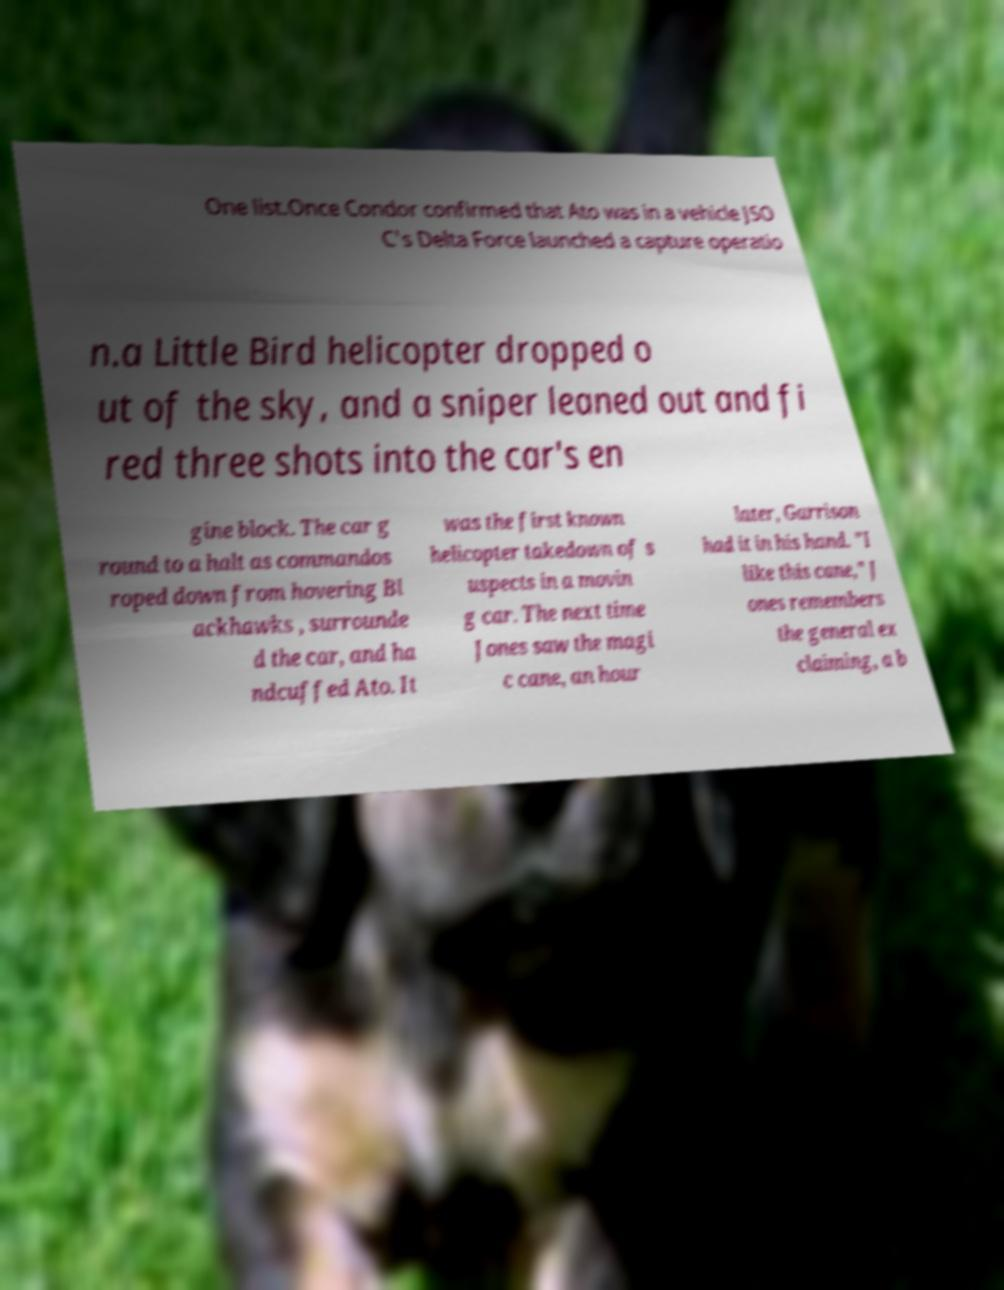Can you read and provide the text displayed in the image?This photo seems to have some interesting text. Can you extract and type it out for me? One list.Once Condor confirmed that Ato was in a vehicle JSO C's Delta Force launched a capture operatio n.a Little Bird helicopter dropped o ut of the sky, and a sniper leaned out and fi red three shots into the car's en gine block. The car g round to a halt as commandos roped down from hovering Bl ackhawks , surrounde d the car, and ha ndcuffed Ato. It was the first known helicopter takedown of s uspects in a movin g car. The next time Jones saw the magi c cane, an hour later, Garrison had it in his hand. "I like this cane," J ones remembers the general ex claiming, a b 